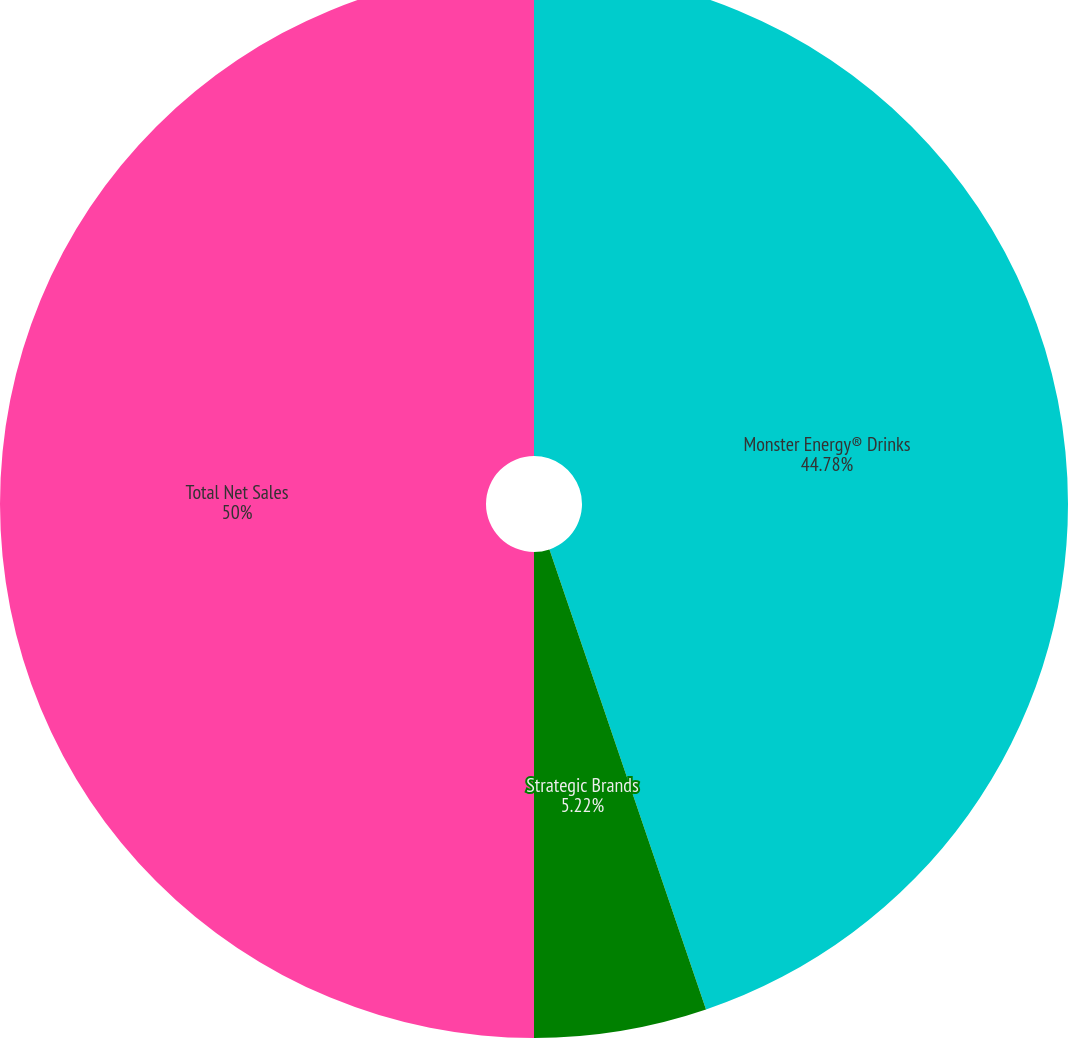<chart> <loc_0><loc_0><loc_500><loc_500><pie_chart><fcel>Monster Energy® Drinks<fcel>Strategic Brands<fcel>Total Net Sales<nl><fcel>44.78%<fcel>5.22%<fcel>50.0%<nl></chart> 